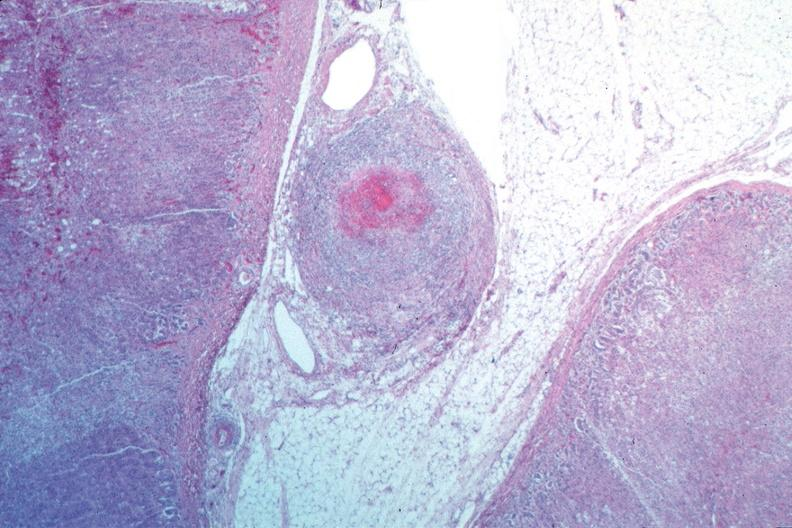s vasculature present?
Answer the question using a single word or phrase. Yes 